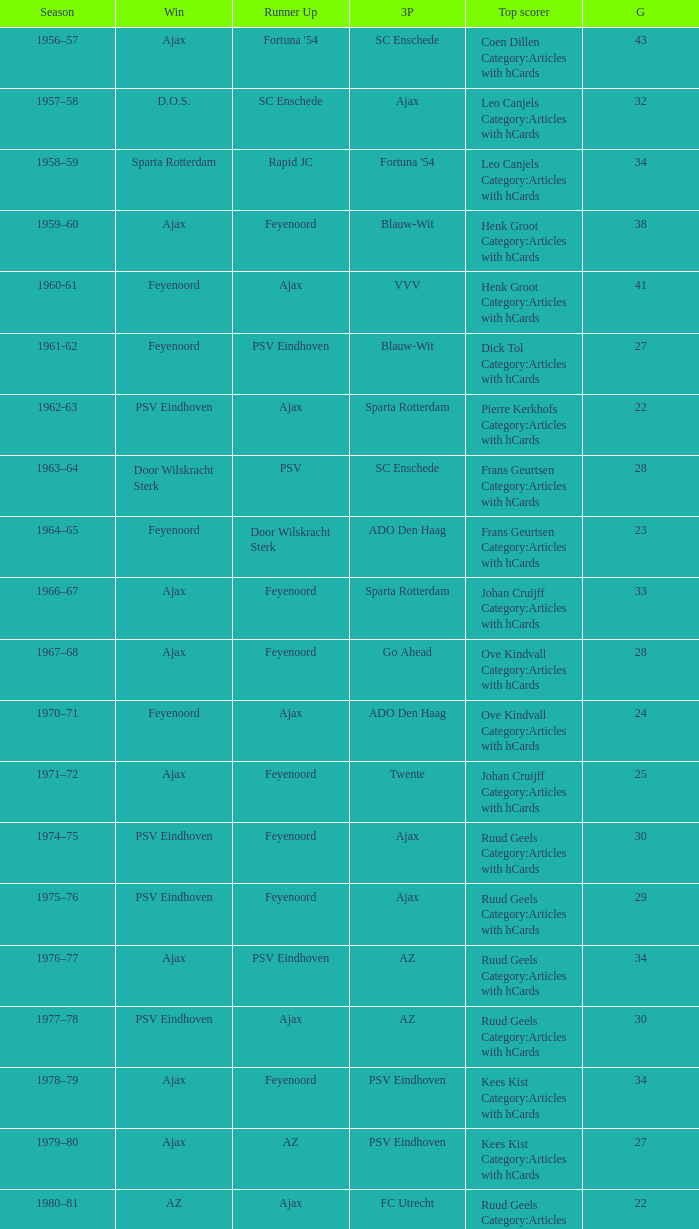When nac breda came in third place and psv eindhoven was the winner who is the top scorer? Klaas-Jan Huntelaar Category:Articles with hCards. Parse the full table. {'header': ['Season', 'Win', 'Runner Up', '3P', 'Top scorer', 'G'], 'rows': [['1956–57', 'Ajax', "Fortuna '54", 'SC Enschede', 'Coen Dillen Category:Articles with hCards', '43'], ['1957–58', 'D.O.S.', 'SC Enschede', 'Ajax', 'Leo Canjels Category:Articles with hCards', '32'], ['1958–59', 'Sparta Rotterdam', 'Rapid JC', "Fortuna '54", 'Leo Canjels Category:Articles with hCards', '34'], ['1959–60', 'Ajax', 'Feyenoord', 'Blauw-Wit', 'Henk Groot Category:Articles with hCards', '38'], ['1960-61', 'Feyenoord', 'Ajax', 'VVV', 'Henk Groot Category:Articles with hCards', '41'], ['1961-62', 'Feyenoord', 'PSV Eindhoven', 'Blauw-Wit', 'Dick Tol Category:Articles with hCards', '27'], ['1962-63', 'PSV Eindhoven', 'Ajax', 'Sparta Rotterdam', 'Pierre Kerkhofs Category:Articles with hCards', '22'], ['1963–64', 'Door Wilskracht Sterk', 'PSV', 'SC Enschede', 'Frans Geurtsen Category:Articles with hCards', '28'], ['1964–65', 'Feyenoord', 'Door Wilskracht Sterk', 'ADO Den Haag', 'Frans Geurtsen Category:Articles with hCards', '23'], ['1966–67', 'Ajax', 'Feyenoord', 'Sparta Rotterdam', 'Johan Cruijff Category:Articles with hCards', '33'], ['1967–68', 'Ajax', 'Feyenoord', 'Go Ahead', 'Ove Kindvall Category:Articles with hCards', '28'], ['1970–71', 'Feyenoord', 'Ajax', 'ADO Den Haag', 'Ove Kindvall Category:Articles with hCards', '24'], ['1971–72', 'Ajax', 'Feyenoord', 'Twente', 'Johan Cruijff Category:Articles with hCards', '25'], ['1974–75', 'PSV Eindhoven', 'Feyenoord', 'Ajax', 'Ruud Geels Category:Articles with hCards', '30'], ['1975–76', 'PSV Eindhoven', 'Feyenoord', 'Ajax', 'Ruud Geels Category:Articles with hCards', '29'], ['1976–77', 'Ajax', 'PSV Eindhoven', 'AZ', 'Ruud Geels Category:Articles with hCards', '34'], ['1977–78', 'PSV Eindhoven', 'Ajax', 'AZ', 'Ruud Geels Category:Articles with hCards', '30'], ['1978–79', 'Ajax', 'Feyenoord', 'PSV Eindhoven', 'Kees Kist Category:Articles with hCards', '34'], ['1979–80', 'Ajax', 'AZ', 'PSV Eindhoven', 'Kees Kist Category:Articles with hCards', '27'], ['1980–81', 'AZ', 'Ajax', 'FC Utrecht', 'Ruud Geels Category:Articles with hCards', '22'], ['1981-82', 'Ajax', 'PSV Eindhoven', 'AZ', 'Wim Kieft Category:Articles with hCards', '32'], ['1982-83', 'Ajax', 'Feyenoord', 'PSV Eindhoven', 'Peter Houtman Category:Articles with hCards', '30'], ['1983-84', 'Feyenoord', 'PSV Eindhoven', 'Ajax', 'Marco van Basten Category:Articles with hCards', '28'], ['1984-85', 'Ajax', 'PSV Eindhoven', 'Feyenoord', 'Marco van Basten Category:Articles with hCards', '22'], ['1985-86', 'PSV Eindhoven', 'Ajax', 'Feyenoord', 'Marco van Basten Category:Articles with hCards', '37'], ['1986-87', 'PSV Eindhoven', 'Ajax', 'Feyenoord', 'Marco van Basten Category:Articles with hCards', '31'], ['1987-88', 'PSV Eindhoven', 'Ajax', 'Twente', 'Wim Kieft Category:Articles with hCards', '29'], ['1988–89', 'PSV Eindhoven', 'Ajax', 'Twente', 'Romário', '19'], ['1989-90', 'Ajax', 'PSV Eindhoven', 'Twente', 'Romário', '23'], ['1990–91', 'PSV Eindhoven', 'Ajax', 'FC Groningen', 'Romário Dennis Bergkamp', '25'], ['1991–92', 'PSV Eindhoven', 'Ajax', 'Feyenoord', 'Dennis Bergkamp Category:Articles with hCards', '22'], ['1992–93', 'Feyenoord', 'PSV Eindhoven', 'Ajax', 'Dennis Bergkamp Category:Articles with hCards', '26'], ['1993–94', 'Ajax', 'Feyenoord', 'PSV Eindhoven', 'Jari Litmanen Category:Articles with hCards', '26'], ['1994–95', 'Ajax', 'Roda JC', 'PSV Eindhoven', 'Ronaldo', '30'], ['1995–96', 'Ajax', 'PSV Eindhoven', 'Feyenoord', 'Luc Nilis Category:Articles with hCards', '21'], ['1996–97', 'PSV Eindhoven', 'Feyenoord', 'Twente', 'Luc Nilis Category:Articles with hCards', '21'], ['1997–98', 'Ajax', 'PSV Eindhoven', 'Vitesse', 'Nikos Machlas Category:Articles with hCards', '34'], ['1998–99', 'Feyenoord', 'Willem II', 'PSV Eindhoven', 'Ruud van Nistelrooy Category:Articles with hCards', '31'], ['1999–2000', 'PSV Eindhoven', 'Heerenveen', 'Feyenoord', 'Ruud van Nistelrooy Category:Articles with hCards', '29'], ['2000–01', 'PSV Eindhoven', 'Feyenoord', 'Ajax', 'Mateja Kežman Category:Articles with hCards', '24'], ['2001–02', 'Ajax', 'PSV Eindhoven', 'Feyenoord', 'Pierre van Hooijdonk Category:Articles with hCards', '24'], ['2002-03', 'PSV Eindhoven', 'Ajax', 'Feyenoord', 'Mateja Kežman Category:Articles with hCards', '35'], ['2003-04', 'Ajax', 'PSV Eindhoven', 'Feyenoord', 'Mateja Kežman Category:Articles with hCards', '31'], ['2004-05', 'PSV Eindhoven', 'Ajax', 'AZ', 'Dirk Kuyt Category:Articles with hCards', '29'], ['2005-06', 'PSV Eindhoven', 'AZ', 'Feyenoord', 'Klaas-Jan Huntelaar Category:Articles with hCards', '33'], ['2006-07', 'PSV Eindhoven', 'Ajax', 'AZ', 'Afonso Alves Category:Articles with hCards', '34'], ['2007-08', 'PSV Eindhoven', 'Ajax', 'NAC Breda', 'Klaas-Jan Huntelaar Category:Articles with hCards', '33'], ['2008-09', 'AZ', 'Twente', 'Ajax', 'Mounir El Hamdaoui Category:Articles with hCards', '23'], ['2009-10', 'Twente', 'Ajax', 'PSV Eindhoven', 'Luis Suárez Category:Articles with hCards', '35'], ['2010-11', 'Ajax', 'Twente', 'PSV Eindhoven', 'Björn Vleminckx Category:Articles with hCards', '23'], ['2011-12', 'Ajax', 'Feyenoord', 'PSV Eindhoven', 'Bas Dost Category:Articles with hCards', '32']]} 